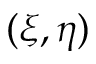<formula> <loc_0><loc_0><loc_500><loc_500>( \xi , \eta )</formula> 